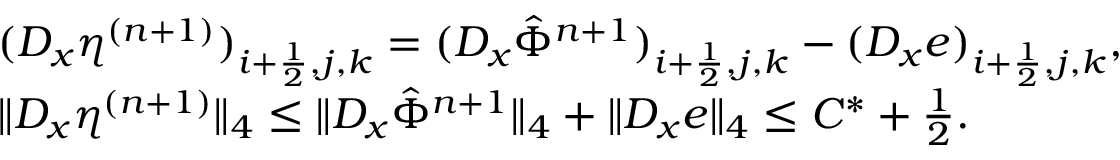Convert formula to latex. <formula><loc_0><loc_0><loc_500><loc_500>\begin{array} { r l } & { ( D _ { x } \eta ^ { ( n + 1 ) } ) _ { i + \frac { 1 } { 2 } , j , k } = ( D _ { x } \hat { \Phi } ^ { n + 1 } ) _ { i + \frac { 1 } { 2 } , j , k } - ( D _ { x } e ) _ { i + \frac { 1 } { 2 } , j , k } , } \\ & { \| D _ { x } \eta ^ { ( n + 1 ) } \| _ { 4 } \leq \| D _ { x } \hat { \Phi } ^ { n + 1 } \| _ { 4 } + \| D _ { x } e \| _ { 4 } \leq C ^ { * } + \frac { 1 } { 2 } . } \end{array}</formula> 